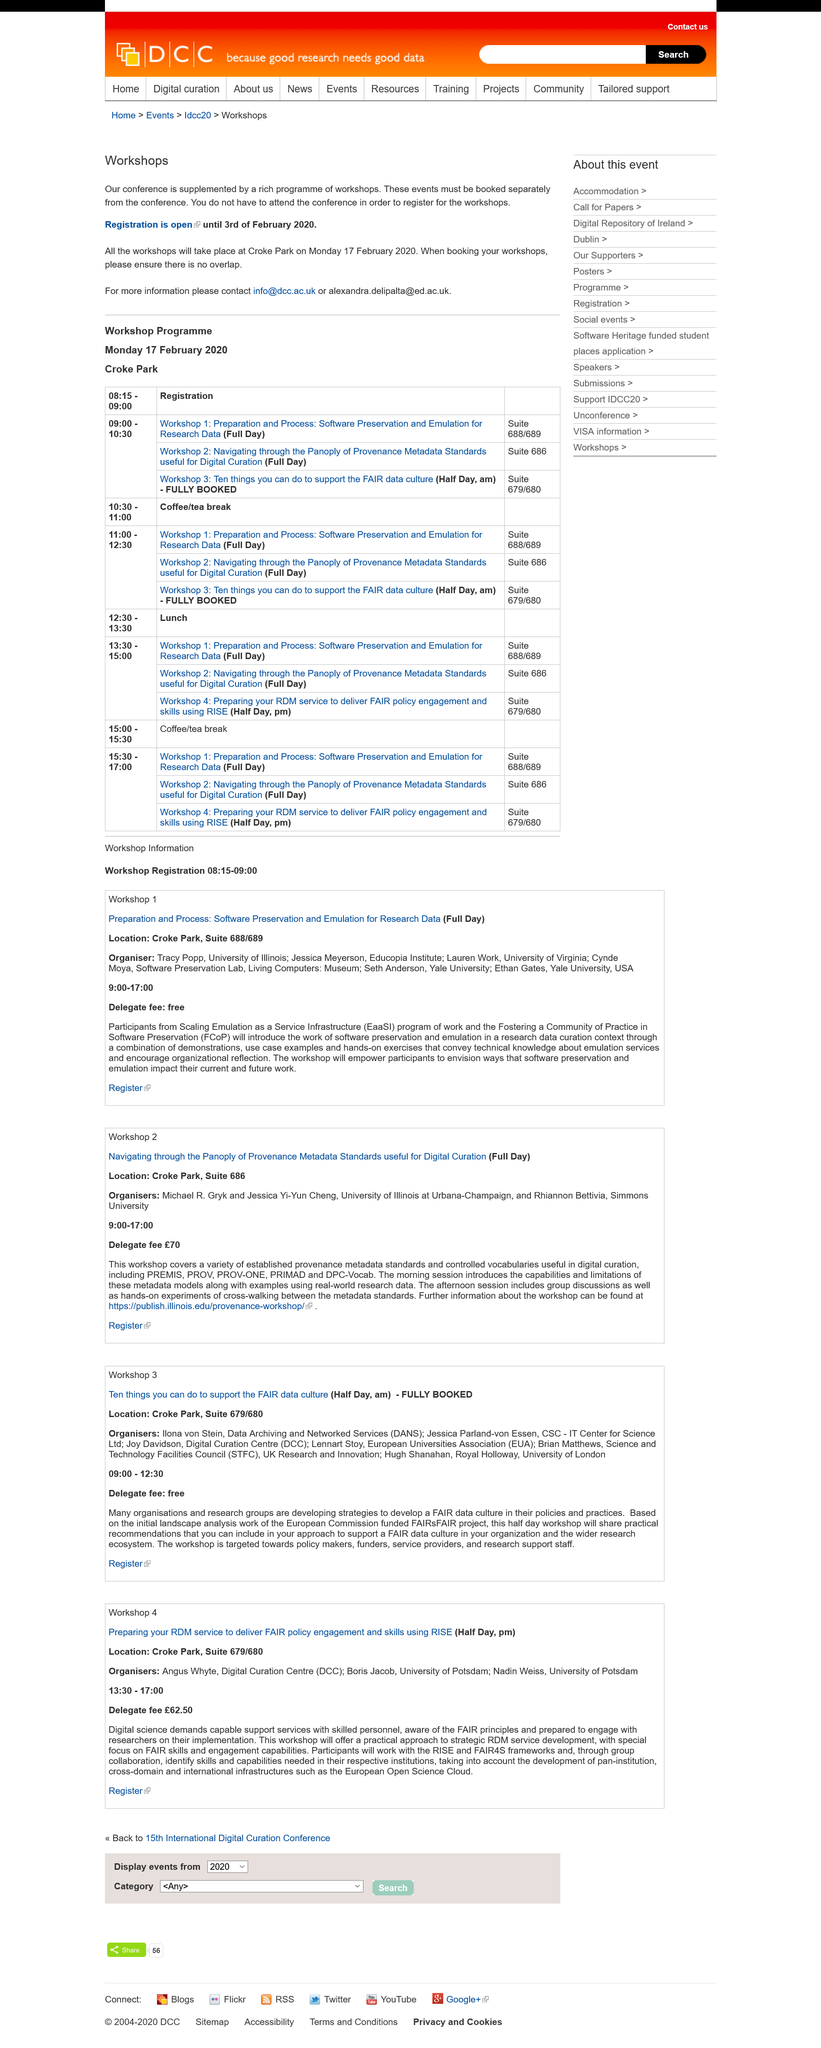List a handful of essential elements in this visual. Angus Whyte is one of the organizers for Workshop 4. Yes, Boris Jacob is one of the organisers for Workshop 4. The European Universities Association, commonly referred to as EUA, is an organization that represents the interests of universities in Europe. Delegates do not pay a fee to attend a workshop, as it is free. The location for Workshop 2 is Croke Park, Suite 686. 